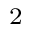Convert formula to latex. <formula><loc_0><loc_0><loc_500><loc_500>^ { 2 }</formula> 